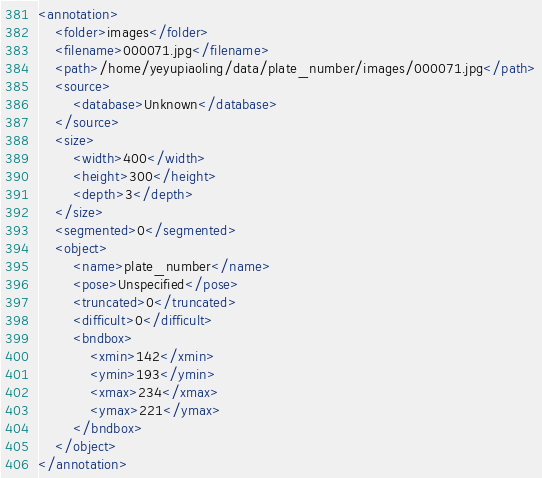Convert code to text. <code><loc_0><loc_0><loc_500><loc_500><_XML_><annotation>
	<folder>images</folder>
	<filename>000071.jpg</filename>
	<path>/home/yeyupiaoling/data/plate_number/images/000071.jpg</path>
	<source>
		<database>Unknown</database>
	</source>
	<size>
		<width>400</width>
		<height>300</height>
		<depth>3</depth>
	</size>
	<segmented>0</segmented>
	<object>
		<name>plate_number</name>
		<pose>Unspecified</pose>
		<truncated>0</truncated>
		<difficult>0</difficult>
		<bndbox>
			<xmin>142</xmin>
			<ymin>193</ymin>
			<xmax>234</xmax>
			<ymax>221</ymax>
		</bndbox>
	</object>
</annotation>
</code> 